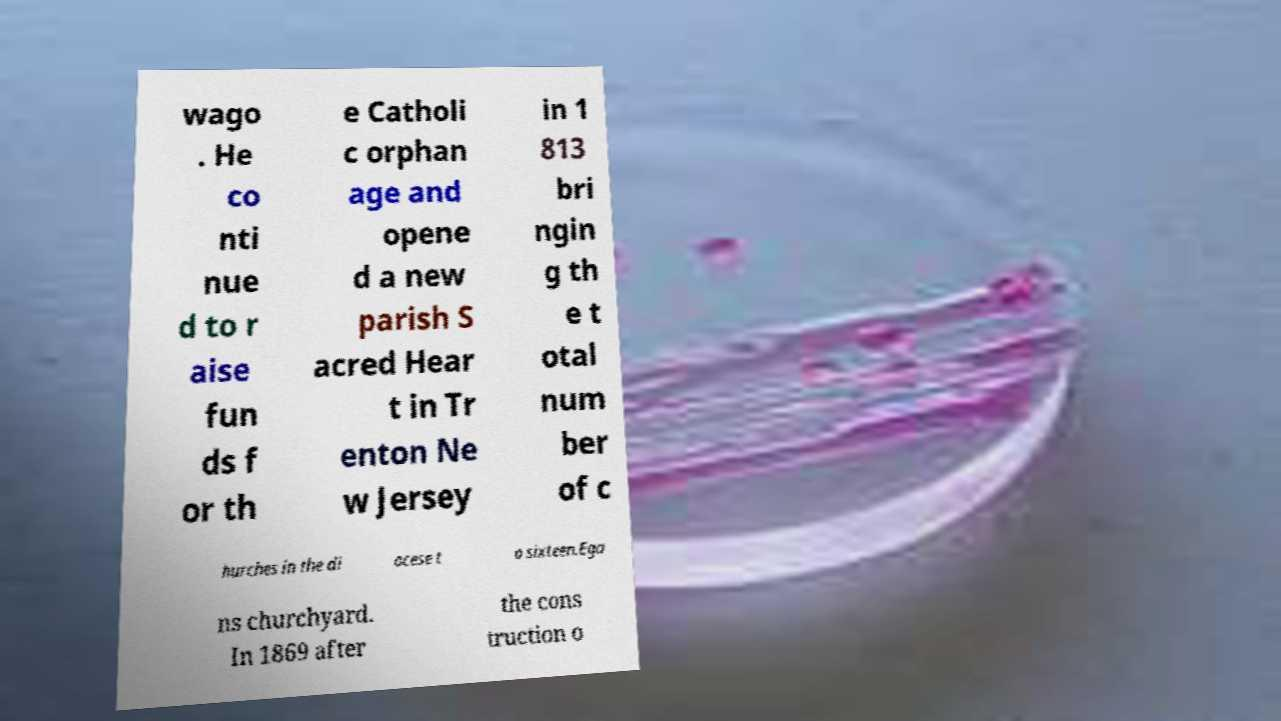What messages or text are displayed in this image? I need them in a readable, typed format. wago . He co nti nue d to r aise fun ds f or th e Catholi c orphan age and opene d a new parish S acred Hear t in Tr enton Ne w Jersey in 1 813 bri ngin g th e t otal num ber of c hurches in the di ocese t o sixteen.Ega ns churchyard. In 1869 after the cons truction o 